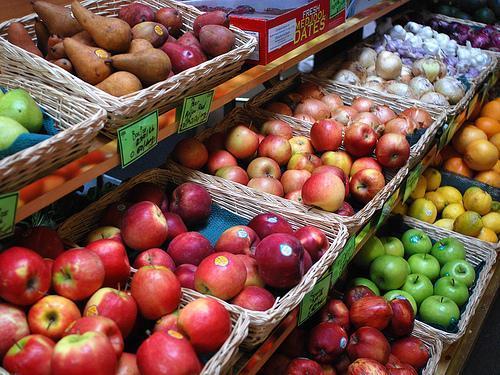How many apples are there?
Give a very brief answer. 6. 